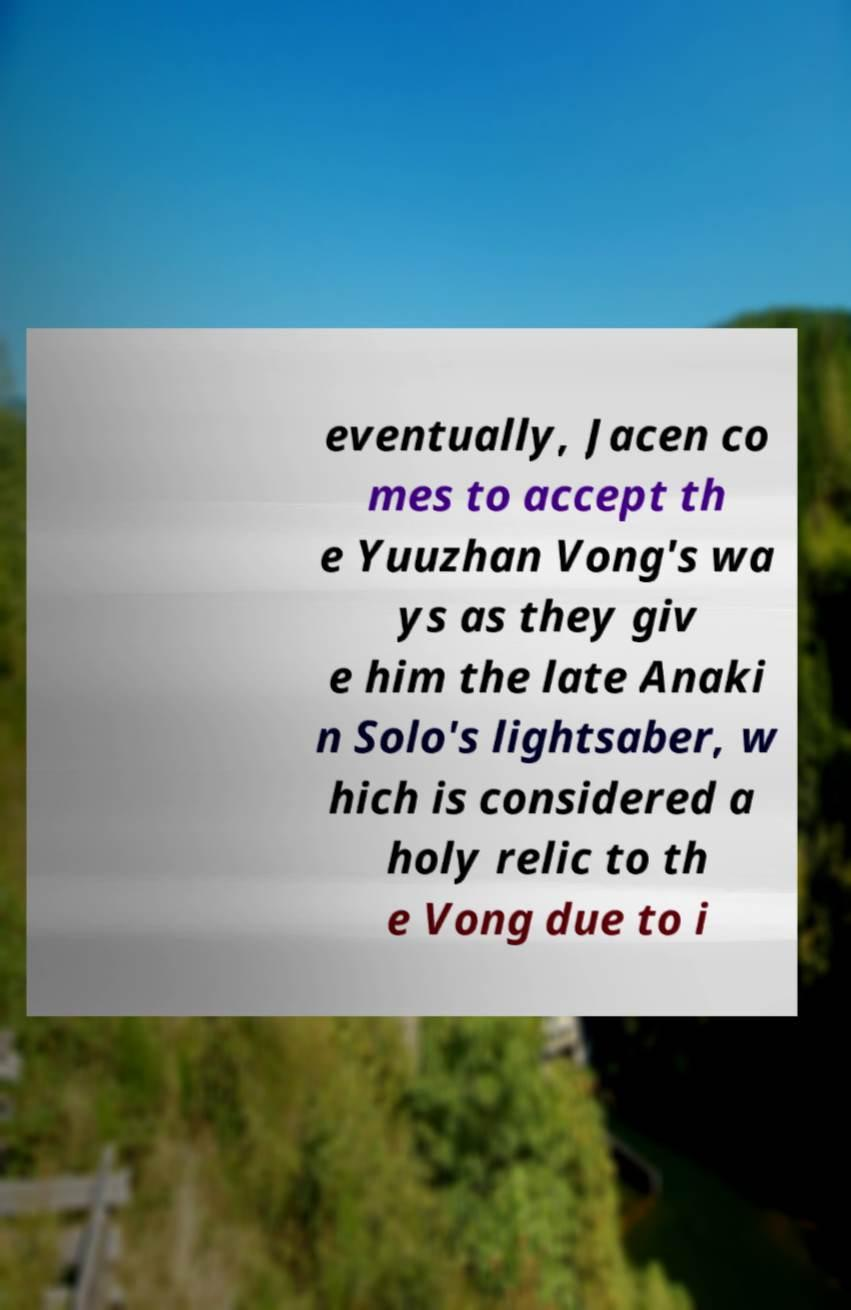What messages or text are displayed in this image? I need them in a readable, typed format. eventually, Jacen co mes to accept th e Yuuzhan Vong's wa ys as they giv e him the late Anaki n Solo's lightsaber, w hich is considered a holy relic to th e Vong due to i 